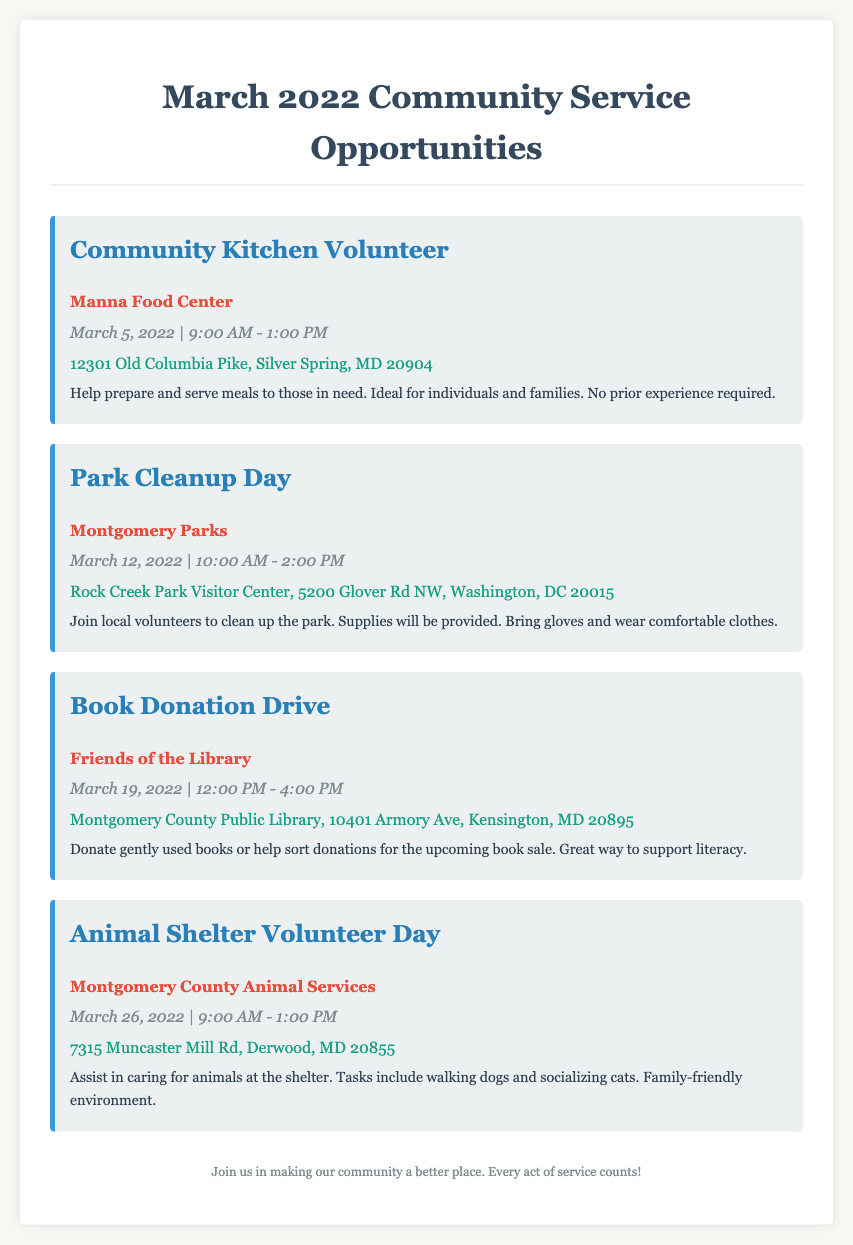What is the first event listed? The first event listed in the document is the "Community Kitchen Volunteer" opportunity.
Answer: Community Kitchen Volunteer What organization is hosting the Park Cleanup Day? The Park Cleanup Day is hosted by Montgomery Parks.
Answer: Montgomery Parks On what date is the Book Donation Drive taking place? The Book Donation Drive is scheduled for March 19, 2022.
Answer: March 19, 2022 What time does the Animal Shelter Volunteer Day start? The Animal Shelter Volunteer Day starts at 9:00 AM.
Answer: 9:00 AM How long is the Community Kitchen Volunteer event? The Community Kitchen Volunteer event lasts for 4 hours, from 9:00 AM to 1:00 PM.
Answer: 4 hours Where will the Park Cleanup Day be held? The Park Cleanup Day will be held at the Rock Creek Park Visitor Center.
Answer: Rock Creek Park Visitor Center What type of donations is needed for the Book Donation Drive? The Book Donation Drive needs gently used books for donation.
Answer: Gently used books Which event allows families to participate? The Animal Shelter Volunteer Day is mentioned as a family-friendly environment.
Answer: Animal Shelter Volunteer Day What is provided during the Park Cleanup Day? Supplies will be provided during the Park Cleanup Day, and participants are encouraged to bring gloves.
Answer: Supplies 